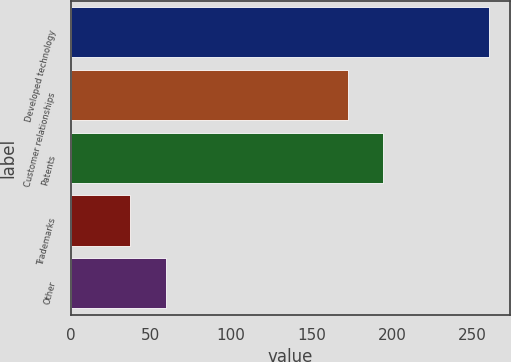Convert chart. <chart><loc_0><loc_0><loc_500><loc_500><bar_chart><fcel>Developed technology<fcel>Customer relationships<fcel>Patents<fcel>Trademarks<fcel>Other<nl><fcel>260.7<fcel>172.4<fcel>194.77<fcel>37<fcel>59.37<nl></chart> 